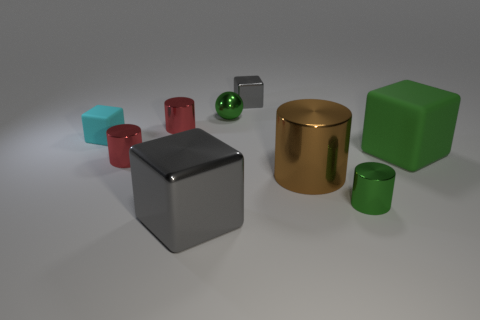Add 1 tiny cyan blocks. How many objects exist? 10 Subtract all blocks. How many objects are left? 5 Subtract all large brown metal cubes. Subtract all tiny green metal balls. How many objects are left? 8 Add 5 green rubber things. How many green rubber things are left? 6 Add 8 green shiny spheres. How many green shiny spheres exist? 9 Subtract 0 brown cubes. How many objects are left? 9 